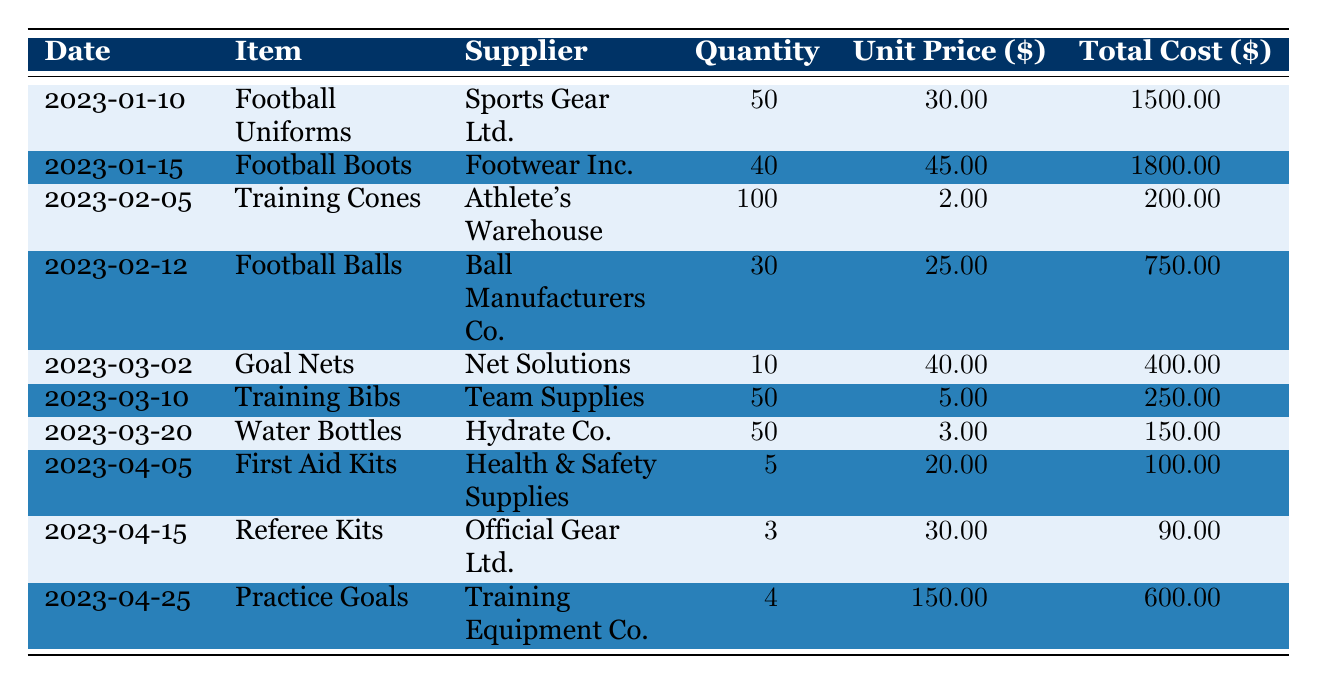What is the total cost of football uniforms purchased? The total cost of football uniforms is listed in the table under the "Total Cost" column for the row containing the item "Football Uniforms." It shows a total cost of 1500.00.
Answer: 1500.00 Who is the supplier for the training cones? The supplier for training cones can be found by looking at the row for "Training Cones" in the "Supplier" column, which lists "Athlete's Warehouse."
Answer: Athlete's Warehouse How many more football boots than practice goals were procured? To find this, subtract the quantity of practice goals (4) from the quantity of football boots (40). Thus, 40 - 4 = 36.
Answer: 36 Did we purchase more water bottles or training bibs? The quantity of water bottles is 50 while the quantity of training bibs is also 50. Since they are equal, the answer is that we did not purchase more of one than the other.
Answer: No What is the average unit price of all items procured? To find the average unit price, first sum all unit prices: 30.00 + 45.00 + 2.00 + 25.00 + 40.00 + 5.00 + 3.00 + 20.00 + 30.00 + 150.00 = 345.00. There are 10 items, so the average is 345.00 / 10 = 34.50.
Answer: 34.50 How much was spent on the referee kits? The total cost for referee kits is specifically listed in the table under the "Total Cost" column for that item, which is 90.00.
Answer: 90.00 Is the total cost of first aid kits less than that of training cones? The total cost of first aid kits is 100.00 and for training cones, it is 200.00. Since 100.00 is less than 200.00, the answer is yes.
Answer: Yes What is the combined total cost of football balls and goal nets? First, find the total costs for football balls (750.00) and goal nets (400.00). Next, sum these values: 750.00 + 400.00 = 1150.00.
Answer: 1150.00 How many items were procured from Health & Safety Supplies? The table specifies that only one item, "First Aid Kits," was procured from Health & Safety Supplies. Thus, the answer is one.
Answer: 1 